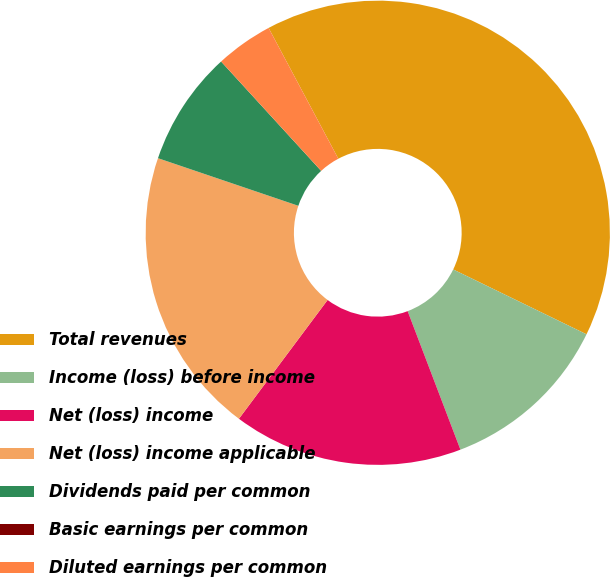Convert chart to OTSL. <chart><loc_0><loc_0><loc_500><loc_500><pie_chart><fcel>Total revenues<fcel>Income (loss) before income<fcel>Net (loss) income<fcel>Net (loss) income applicable<fcel>Dividends paid per common<fcel>Basic earnings per common<fcel>Diluted earnings per common<nl><fcel>40.0%<fcel>12.0%<fcel>16.0%<fcel>20.0%<fcel>8.0%<fcel>0.0%<fcel>4.0%<nl></chart> 